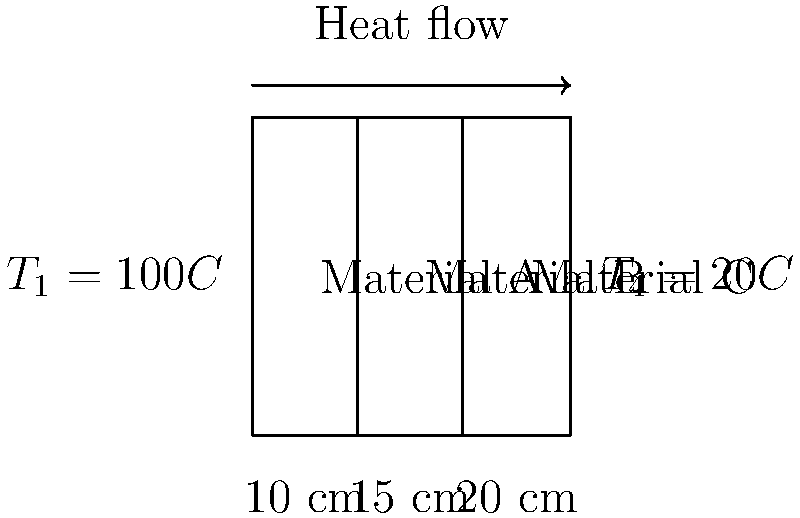In a composite wall consisting of three materials (A, B, and C) with thicknesses of 10 cm, 15 cm, and 20 cm respectively, the temperature on the left side is 100°C and on the right side is 20°C. If the thermal conductivities of materials A, B, and C are 0.5 W/m·K, 0.3 W/m·K, and 0.2 W/m·K respectively, calculate the heat flux through the wall. How might this information be relevant when designing shelters in conflict zones? To solve this problem, we'll use the concept of thermal resistance in series for a composite wall. The steps are as follows:

1) Calculate the thermal resistance for each material:
   $R = \frac{L}{kA}$, where L is thickness, k is thermal conductivity, and A is area (assume 1 m² for simplicity)

   $R_A = \frac{0.10}{0.5 \cdot 1} = 0.20$ m²·K/W
   $R_B = \frac{0.15}{0.3 \cdot 1} = 0.50$ m²·K/W
   $R_C = \frac{0.20}{0.2 \cdot 1} = 1.00$ m²·K/W

2) Calculate the total thermal resistance:
   $R_{total} = R_A + R_B + R_C = 0.20 + 0.50 + 1.00 = 1.70$ m²·K/W

3) Calculate the heat flux using Fourier's Law:
   $q = \frac{\Delta T}{R_{total}} = \frac{100 - 20}{1.70} = 47.06$ W/m²

This information is relevant for designing shelters in conflict zones because:

1) It helps in selecting appropriate materials for insulation, which is crucial for protecting against extreme temperatures.
2) Proper insulation can reduce energy consumption for heating or cooling, important in resource-scarce environments.
3) Understanding heat transfer can aid in designing structures that provide better protection against fire, a common hazard in conflict zones.
4) This knowledge can be applied to design temporary shelters that maintain comfortable living conditions in various climates.
Answer: 47.06 W/m² 